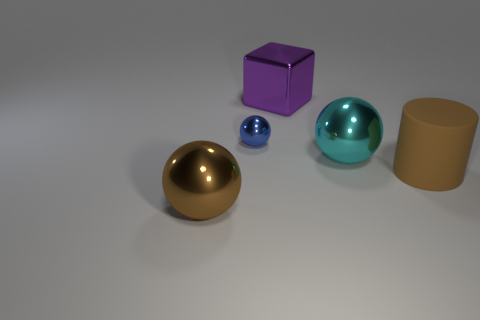What is the material of the thing that is both on the left side of the shiny cube and in front of the tiny thing?
Provide a short and direct response. Metal. Is there anything else that has the same color as the rubber object?
Your response must be concise. Yes. Are there fewer cyan metallic spheres that are to the left of the brown shiny ball than metal cubes?
Offer a very short reply. Yes. Are there more large brown matte cylinders than tiny cyan metal cylinders?
Provide a succinct answer. Yes. Are there any brown rubber things left of the blue sphere to the left of the brown thing that is behind the big brown ball?
Give a very brief answer. No. How many other objects are there of the same size as the purple object?
Offer a very short reply. 3. Are there any large spheres on the right side of the purple object?
Keep it short and to the point. Yes. Is the color of the big cylinder the same as the large sphere that is in front of the cyan shiny sphere?
Provide a succinct answer. Yes. What is the color of the large metal thing that is in front of the shiny ball that is to the right of the thing behind the blue object?
Ensure brevity in your answer.  Brown. Is there another large metallic thing of the same shape as the cyan thing?
Your answer should be compact. Yes. 